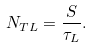Convert formula to latex. <formula><loc_0><loc_0><loc_500><loc_500>N _ { T L } = \frac { S } { \tau _ { L } } .</formula> 